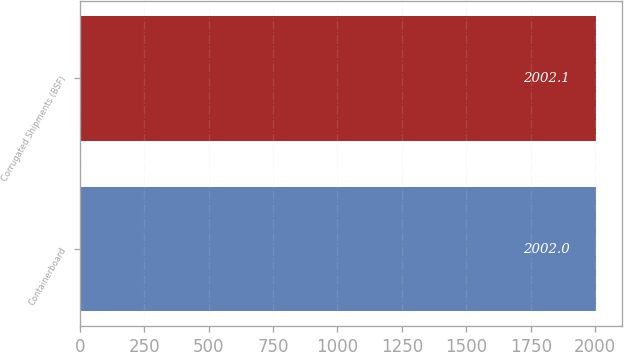Convert chart to OTSL. <chart><loc_0><loc_0><loc_500><loc_500><bar_chart><fcel>Containerboard<fcel>Corrugated Shipments (BSF)<nl><fcel>2002<fcel>2002.1<nl></chart> 